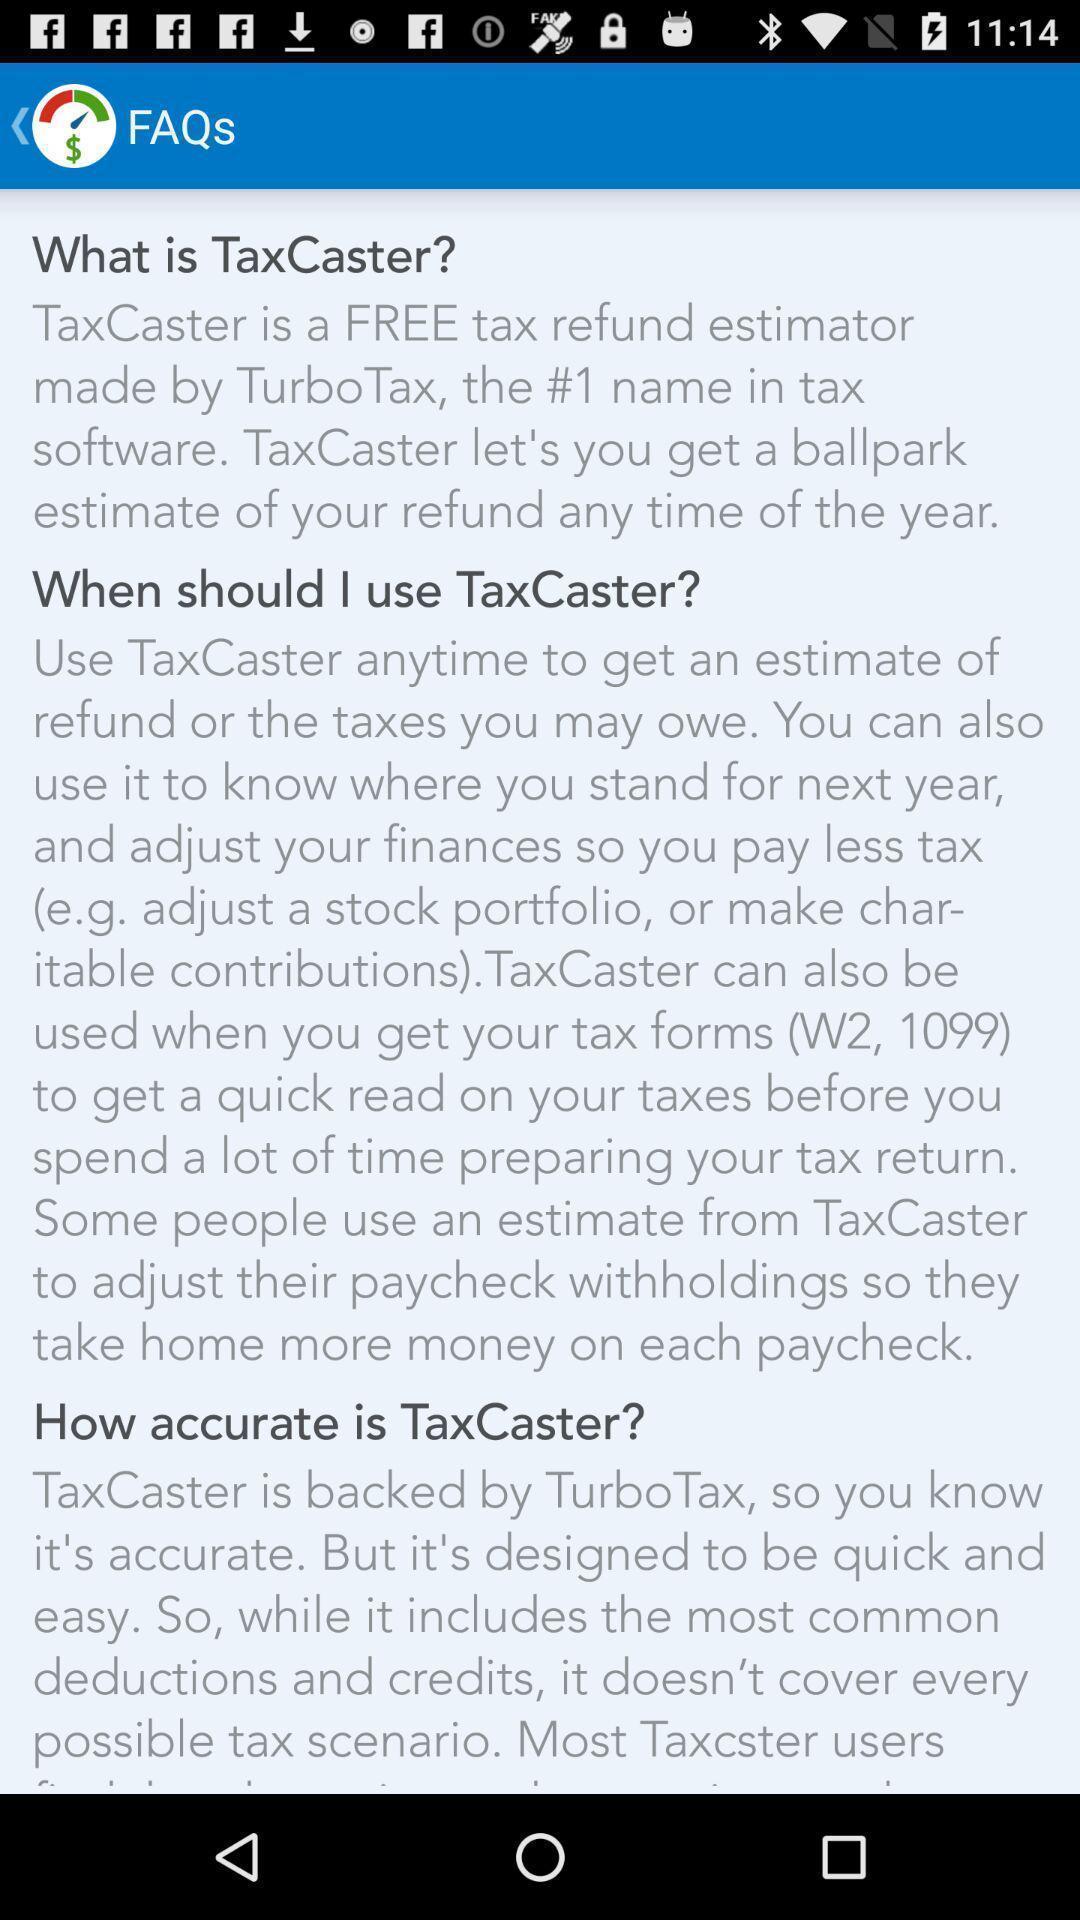Please provide a description for this image. Screen displaying a list of frequently asked questions. 